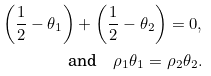<formula> <loc_0><loc_0><loc_500><loc_500>\left ( \frac { 1 } { 2 } - \theta _ { 1 } \right ) + \left ( \frac { 1 } { 2 } - \theta _ { 2 } \right ) = 0 , \\ \text {and} \quad \rho _ { 1 } \theta _ { 1 } = \rho _ { 2 } \theta _ { 2 } .</formula> 